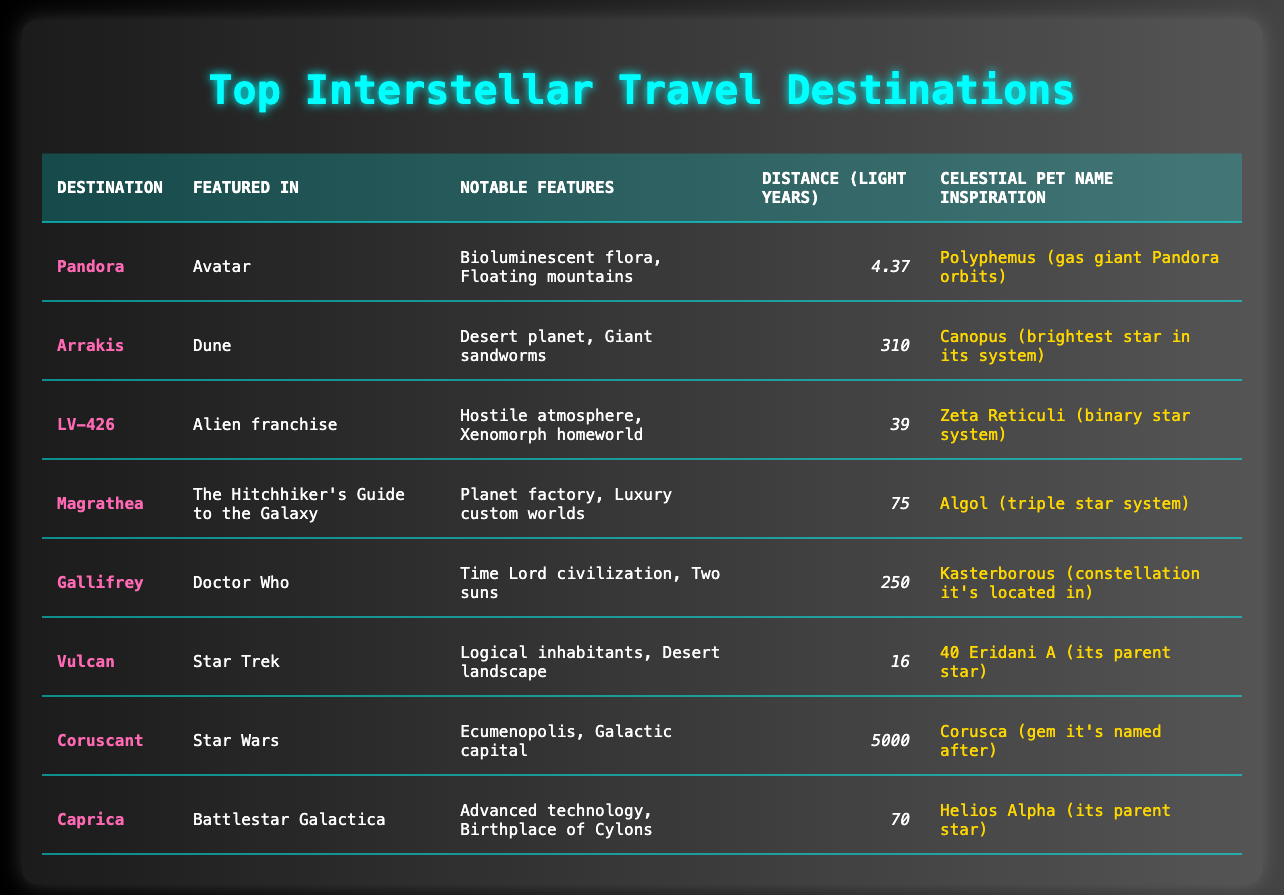What is the distance to Pandora? The distance of Pandora is stated clearly in the table under the "Distance (Light Years)" column, which shows 4.37 light years.
Answer: 4.37 Which destination is featured in "Dune"? The table lists Arrakis as the destination featured in "Dune." It can be found under the "Featured In" column corresponding to Arrakis.
Answer: Arrakis Is LV-426 farther away than Vulcan? To compare the distances, we look at the distances of each destination in the table. LV-426 is 39 light years away, while Vulcan is 16 light years away. Since 39 is greater than 16, LV-426 is indeed farther away.
Answer: Yes What notable features are associated with Gallifrey? The notable features of Gallifrey are specified in the table and they are "Time Lord civilization, Two suns." This information is listed in the "Notable Features" column corresponding to the Gallifrey row.
Answer: Time Lord civilization, Two suns What is the average distance of the top three closest destinations? The closest destinations from the table are Pandora (4.37), Vulcan (16), and LV-426 (39). To find the average, we first add these three distances (4.37 + 16 + 39 = 59.37) and then divide by 3 (59.37 / 3 = 19.79).
Answer: 19.79 Which celestial pet name is inspired by Coruscant? The table provides the pet name inspiration for Coruscant as "Corusca (gem it's named after)" under the "Celestial Pet Name Inspiration" column associated with Coruscant.
Answer: Corusca (gem it's named after) How many destinations are closer than 100 light years? Looking at the distance column, we can see the distances for Pandora (4.37), Vulcan (16), LV-426 (39), Magrathea (75), and Caprica (70). The destinations that are under 100 light years are Pandora, Vulcan, LV-426, Magrathea, and Caprica. This gives us a total of 5 destinations that are closer than 100 light years.
Answer: 5 Is Arrakis the only desert planet listed in the table? According to the information in the table, Arrakis is indeed classified as a desert planet. Checking the other entries, none of the other listed destinations specify that they are desert planets. Therefore, Arrakis is the only one mentioned.
Answer: Yes What distance separates Coruscant from the next closest destination? Coruscant is listed with a distance of 5000 light years and the next closest destination in the table is Gallifrey at 250 light years. To find the distance that separates them, we subtract Gallifrey's distance from Coruscant's distance (5000 - 250 = 4750).
Answer: 4750 